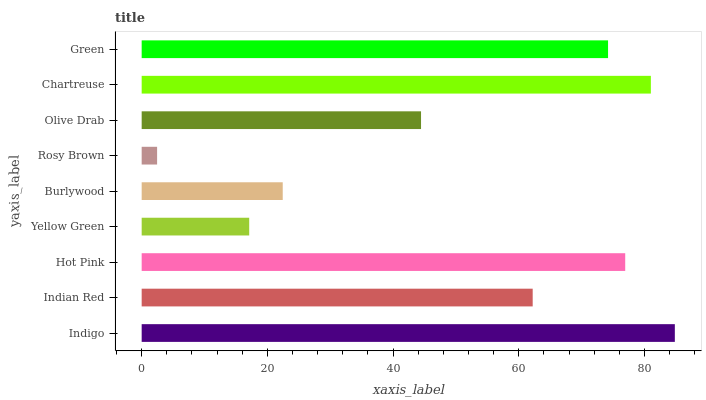Is Rosy Brown the minimum?
Answer yes or no. Yes. Is Indigo the maximum?
Answer yes or no. Yes. Is Indian Red the minimum?
Answer yes or no. No. Is Indian Red the maximum?
Answer yes or no. No. Is Indigo greater than Indian Red?
Answer yes or no. Yes. Is Indian Red less than Indigo?
Answer yes or no. Yes. Is Indian Red greater than Indigo?
Answer yes or no. No. Is Indigo less than Indian Red?
Answer yes or no. No. Is Indian Red the high median?
Answer yes or no. Yes. Is Indian Red the low median?
Answer yes or no. Yes. Is Green the high median?
Answer yes or no. No. Is Green the low median?
Answer yes or no. No. 